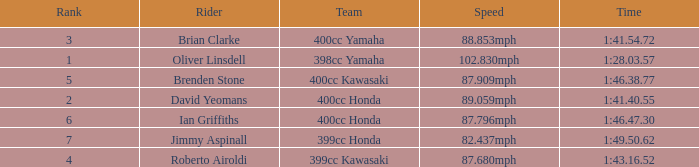What is the rank of the rider with time of 1:41.40.55? 2.0. 